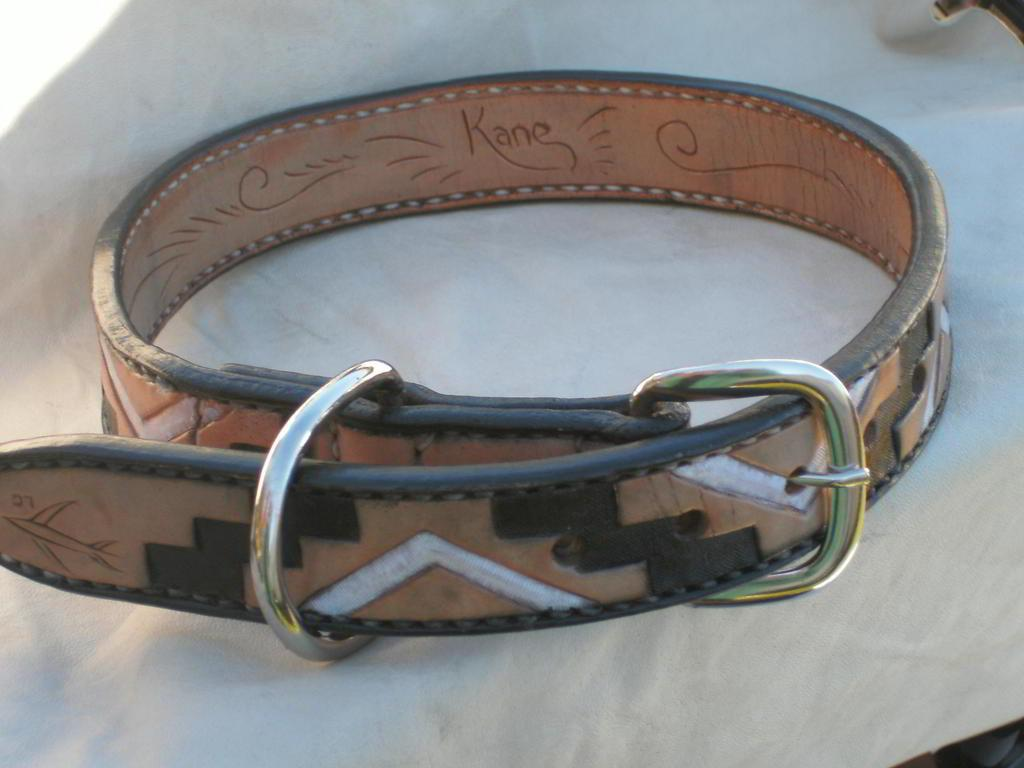<image>
Present a compact description of the photo's key features. "Kane" is written on the inside of a belt. 